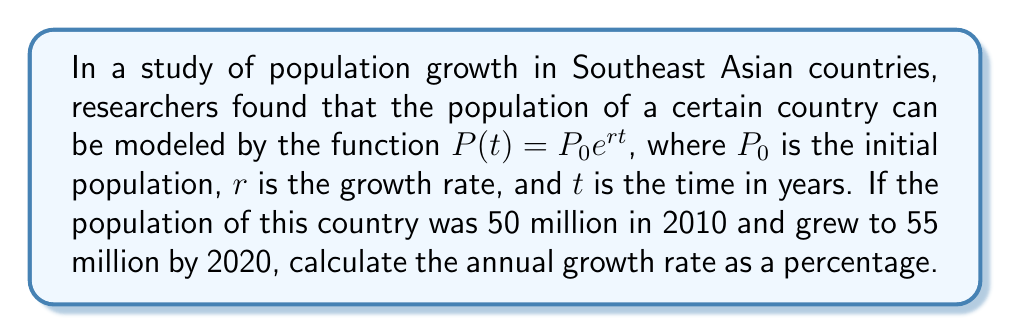Teach me how to tackle this problem. To solve this problem, we'll use the exponential growth model and the given information:

1) The exponential growth function is $P(t) = P_0e^{rt}$

2) We know:
   $P_0 = 50$ million (population in 2010)
   $P(10) = 55$ million (population in 2020, 10 years later)
   $t = 10$ years

3) Let's substitute these values into the equation:
   $55 = 50e^{10r}$

4) Divide both sides by 50:
   $\frac{55}{50} = e^{10r}$

5) Take the natural logarithm of both sides:
   $\ln(\frac{55}{50}) = \ln(e^{10r})$

6) Simplify the right side using the properties of logarithms:
   $\ln(\frac{55}{50}) = 10r$

7) Solve for $r$:
   $r = \frac{\ln(\frac{55}{50})}{10}$

8) Calculate the value:
   $r = \frac{\ln(1.1)}{10} \approx 0.00953$

9) Convert to a percentage by multiplying by 100:
   Annual growth rate = $0.00953 \times 100 \approx 0.953\%$

This approach uses concepts from exponential functions and logarithms, which are fundamental in modeling population growth in real-world scenarios.
Answer: The annual population growth rate is approximately 0.953%. 